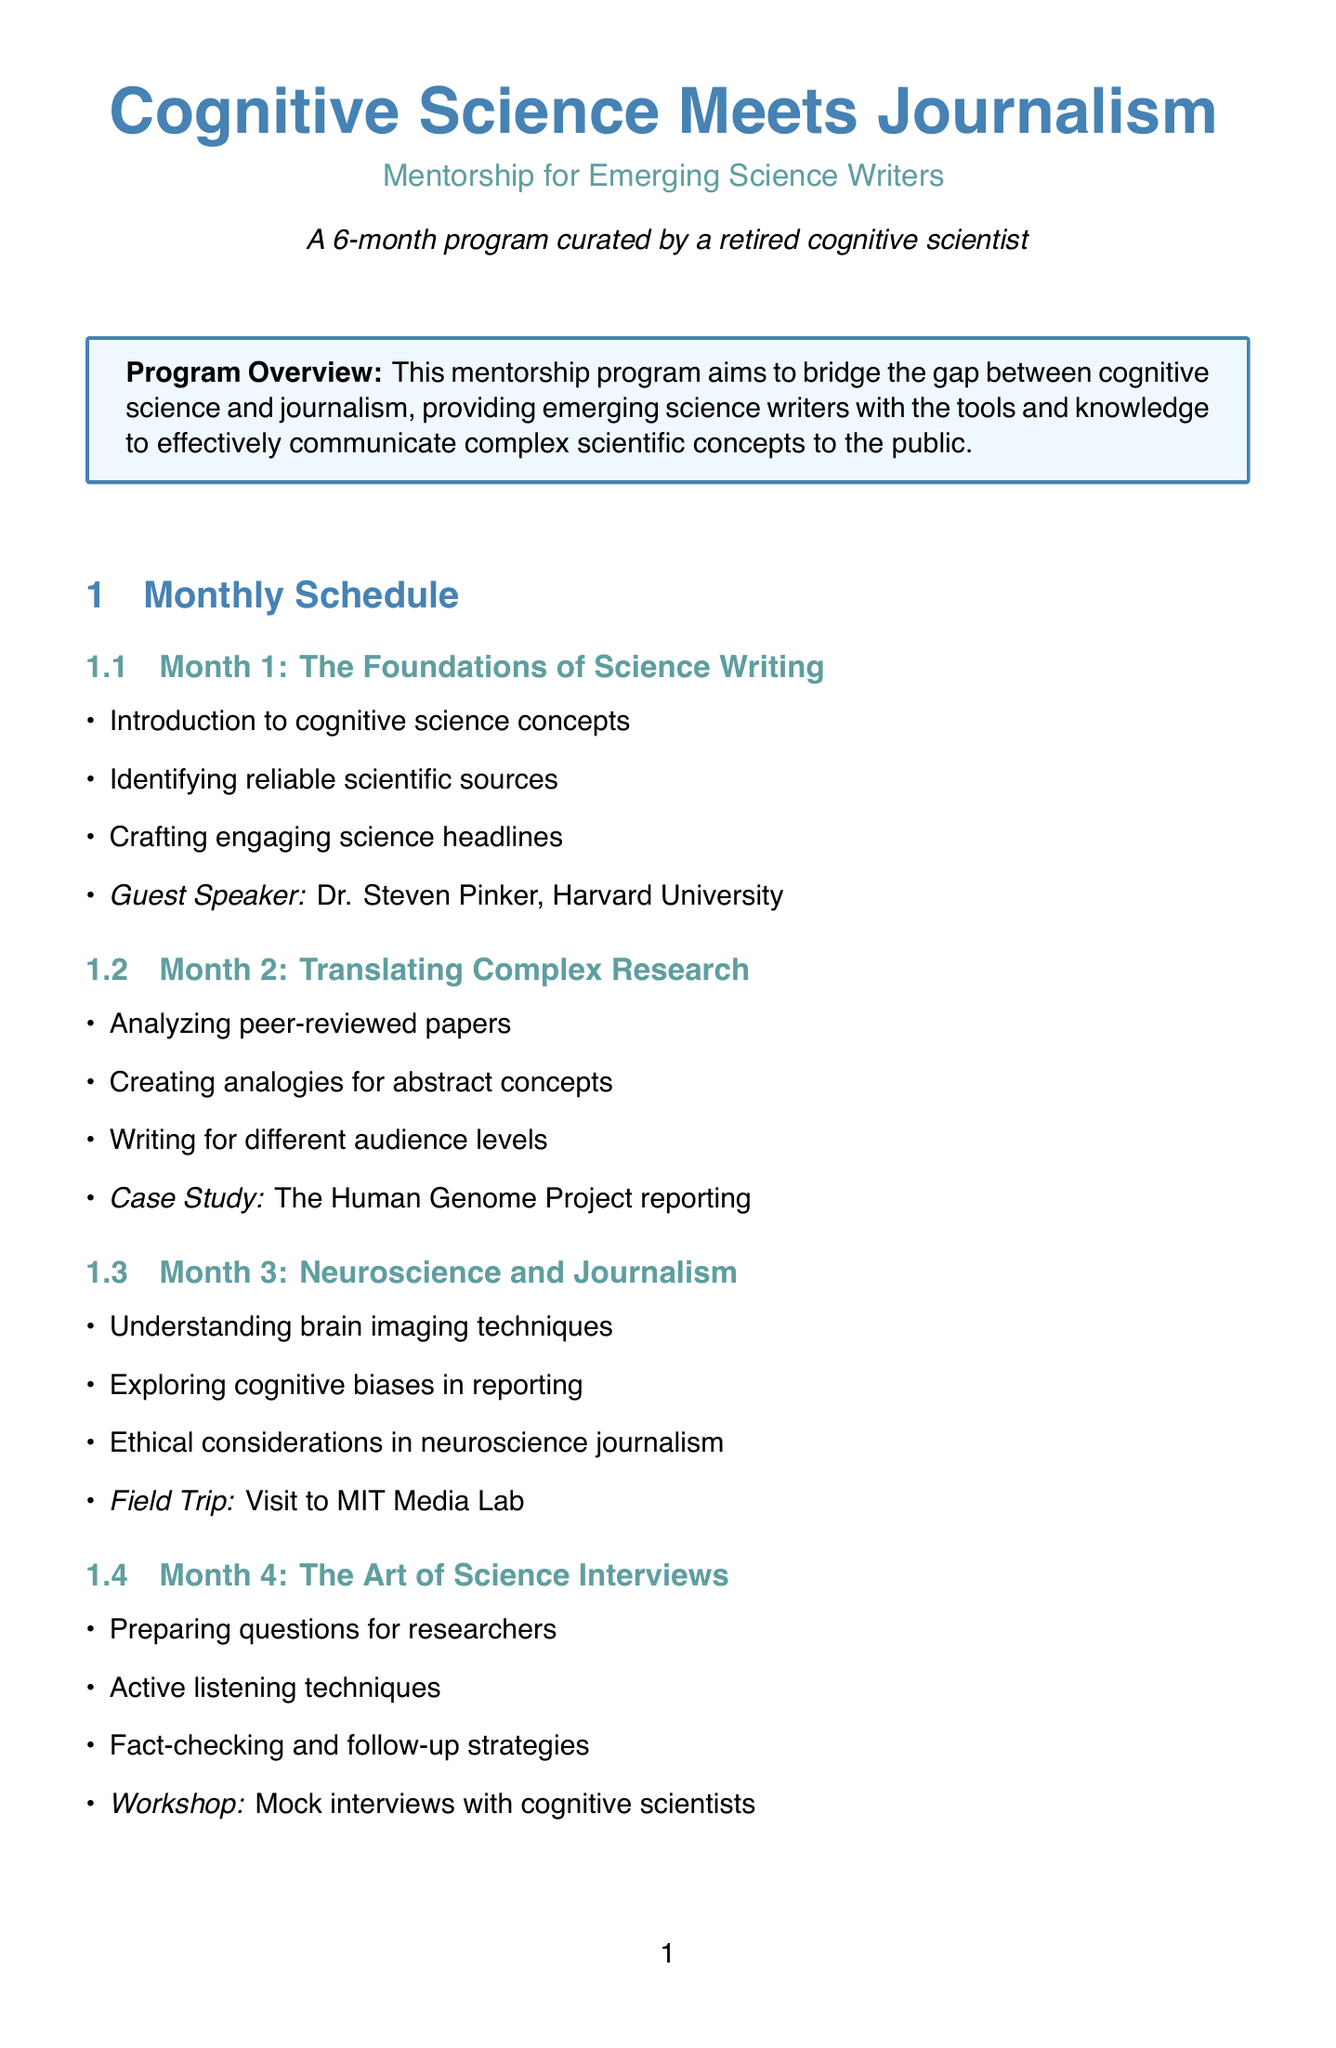What is the program name? The program name is specifically stated in the document as the title of the mentorship initiative.
Answer: Cognitive Science Meets Journalism: Mentorship for Emerging Science Writers Who is the guest speaker for Month 1? The guest speaker is mentioned in the activities for Month 1, highlighting their affiliation and expertise.
Answer: Dr. Steven Pinker, Harvard University What is the main focus of Month 5? The main topic for Month 5 is listed, summarizing the theme of the activities planned for that month.
Answer: Multimedia Science Storytelling How long is the mentorship program? The duration of the program is explicitly mentioned in the overview section of the document.
Answer: 6 months Which institution's Media Lab is visited in Month 3? The location of the field trip in Month 3 is given, indicating the specific institution being referenced.
Answer: MIT Media Lab What type of project do mentees develop in Month 5? The document details the nature of the project that participants are tasked with in Month 5.
Answer: Develop a multimedia piece on a recent cognitive science breakthrough What is one of the activities in Month 4? An activity from Month 4 is included to illustrate the skills being developed during that session.
Answer: Active listening techniques What additional resource is provided in the mentorship program? There are multiple resources mentioned, but this question refers to one type specifically.
Answer: Book, Online Course, Webinar Series What is the final project for the mentorship program? The final project is clearly defined in the mentorship approach section, summarizing what mentees are expected to produce at the end.
Answer: Feature-length article on a cognitive science topic for a major publication 